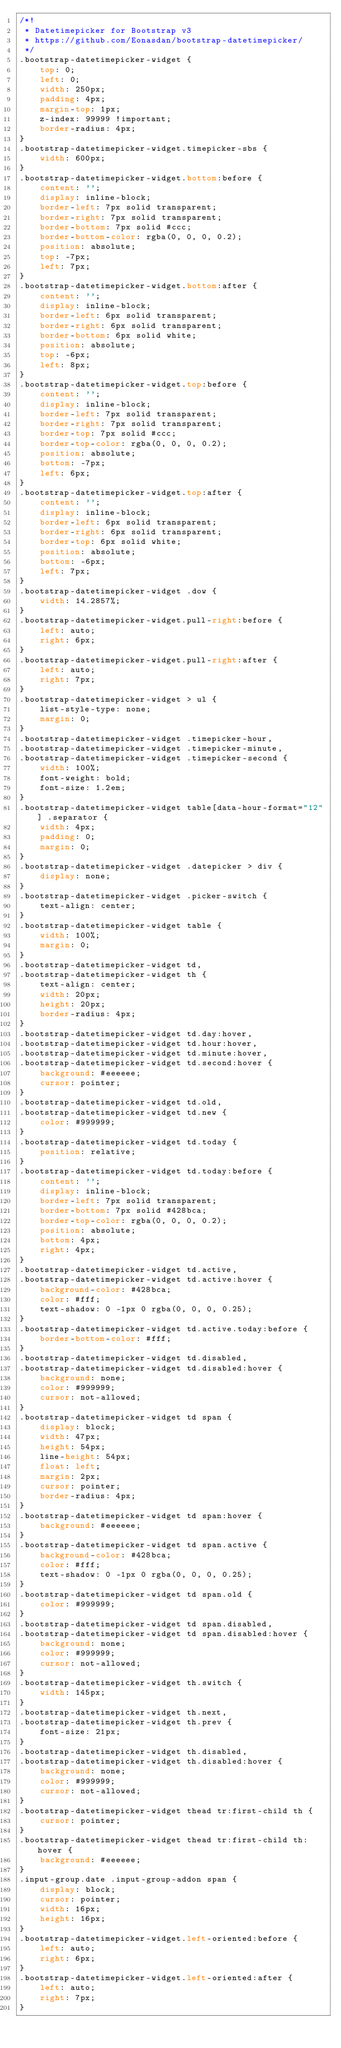Convert code to text. <code><loc_0><loc_0><loc_500><loc_500><_CSS_>/*!
 * Datetimepicker for Bootstrap v3
 * https://github.com/Eonasdan/bootstrap-datetimepicker/
 */
.bootstrap-datetimepicker-widget {
    top: 0;
    left: 0;
    width: 250px;
    padding: 4px;
    margin-top: 1px;
    z-index: 99999 !important;
    border-radius: 4px;
}
.bootstrap-datetimepicker-widget.timepicker-sbs {
    width: 600px;
}
.bootstrap-datetimepicker-widget.bottom:before {
    content: '';
    display: inline-block;
    border-left: 7px solid transparent;
    border-right: 7px solid transparent;
    border-bottom: 7px solid #ccc;
    border-bottom-color: rgba(0, 0, 0, 0.2);
    position: absolute;
    top: -7px;
    left: 7px;
}
.bootstrap-datetimepicker-widget.bottom:after {
    content: '';
    display: inline-block;
    border-left: 6px solid transparent;
    border-right: 6px solid transparent;
    border-bottom: 6px solid white;
    position: absolute;
    top: -6px;
    left: 8px;
}
.bootstrap-datetimepicker-widget.top:before {
    content: '';
    display: inline-block;
    border-left: 7px solid transparent;
    border-right: 7px solid transparent;
    border-top: 7px solid #ccc;
    border-top-color: rgba(0, 0, 0, 0.2);
    position: absolute;
    bottom: -7px;
    left: 6px;
}
.bootstrap-datetimepicker-widget.top:after {
    content: '';
    display: inline-block;
    border-left: 6px solid transparent;
    border-right: 6px solid transparent;
    border-top: 6px solid white;
    position: absolute;
    bottom: -6px;
    left: 7px;
}
.bootstrap-datetimepicker-widget .dow {
    width: 14.2857%;
}
.bootstrap-datetimepicker-widget.pull-right:before {
    left: auto;
    right: 6px;
}
.bootstrap-datetimepicker-widget.pull-right:after {
    left: auto;
    right: 7px;
}
.bootstrap-datetimepicker-widget > ul {
    list-style-type: none;
    margin: 0;
}
.bootstrap-datetimepicker-widget .timepicker-hour,
.bootstrap-datetimepicker-widget .timepicker-minute,
.bootstrap-datetimepicker-widget .timepicker-second {
    width: 100%;
    font-weight: bold;
    font-size: 1.2em;
}
.bootstrap-datetimepicker-widget table[data-hour-format="12"] .separator {
    width: 4px;
    padding: 0;
    margin: 0;
}
.bootstrap-datetimepicker-widget .datepicker > div {
    display: none;
}
.bootstrap-datetimepicker-widget .picker-switch {
    text-align: center;
}
.bootstrap-datetimepicker-widget table {
    width: 100%;
    margin: 0;
}
.bootstrap-datetimepicker-widget td,
.bootstrap-datetimepicker-widget th {
    text-align: center;
    width: 20px;
    height: 20px;
    border-radius: 4px;
}
.bootstrap-datetimepicker-widget td.day:hover,
.bootstrap-datetimepicker-widget td.hour:hover,
.bootstrap-datetimepicker-widget td.minute:hover,
.bootstrap-datetimepicker-widget td.second:hover {
    background: #eeeeee;
    cursor: pointer;
}
.bootstrap-datetimepicker-widget td.old,
.bootstrap-datetimepicker-widget td.new {
    color: #999999;
}
.bootstrap-datetimepicker-widget td.today {
    position: relative;
}
.bootstrap-datetimepicker-widget td.today:before {
    content: '';
    display: inline-block;
    border-left: 7px solid transparent;
    border-bottom: 7px solid #428bca;
    border-top-color: rgba(0, 0, 0, 0.2);
    position: absolute;
    bottom: 4px;
    right: 4px;
}
.bootstrap-datetimepicker-widget td.active,
.bootstrap-datetimepicker-widget td.active:hover {
    background-color: #428bca;
    color: #fff;
    text-shadow: 0 -1px 0 rgba(0, 0, 0, 0.25);
}
.bootstrap-datetimepicker-widget td.active.today:before {
    border-bottom-color: #fff;
}
.bootstrap-datetimepicker-widget td.disabled,
.bootstrap-datetimepicker-widget td.disabled:hover {
    background: none;
    color: #999999;
    cursor: not-allowed;
}
.bootstrap-datetimepicker-widget td span {
    display: block;
    width: 47px;
    height: 54px;
    line-height: 54px;
    float: left;
    margin: 2px;
    cursor: pointer;
    border-radius: 4px;
}
.bootstrap-datetimepicker-widget td span:hover {
    background: #eeeeee;
}
.bootstrap-datetimepicker-widget td span.active {
    background-color: #428bca;
    color: #fff;
    text-shadow: 0 -1px 0 rgba(0, 0, 0, 0.25);
}
.bootstrap-datetimepicker-widget td span.old {
    color: #999999;
}
.bootstrap-datetimepicker-widget td span.disabled,
.bootstrap-datetimepicker-widget td span.disabled:hover {
    background: none;
    color: #999999;
    cursor: not-allowed;
}
.bootstrap-datetimepicker-widget th.switch {
    width: 145px;
}
.bootstrap-datetimepicker-widget th.next,
.bootstrap-datetimepicker-widget th.prev {
    font-size: 21px;
}
.bootstrap-datetimepicker-widget th.disabled,
.bootstrap-datetimepicker-widget th.disabled:hover {
    background: none;
    color: #999999;
    cursor: not-allowed;
}
.bootstrap-datetimepicker-widget thead tr:first-child th {
    cursor: pointer;
}
.bootstrap-datetimepicker-widget thead tr:first-child th:hover {
    background: #eeeeee;
}
.input-group.date .input-group-addon span {
    display: block;
    cursor: pointer;
    width: 16px;
    height: 16px;
}
.bootstrap-datetimepicker-widget.left-oriented:before {
    left: auto;
    right: 6px;
}
.bootstrap-datetimepicker-widget.left-oriented:after {
    left: auto;
    right: 7px;
}</code> 